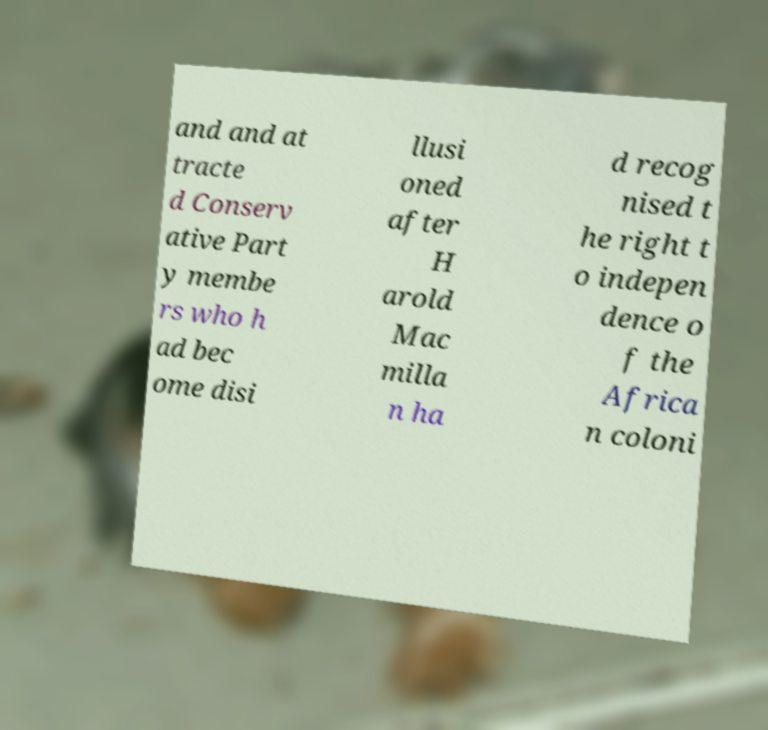What messages or text are displayed in this image? I need them in a readable, typed format. and and at tracte d Conserv ative Part y membe rs who h ad bec ome disi llusi oned after H arold Mac milla n ha d recog nised t he right t o indepen dence o f the Africa n coloni 